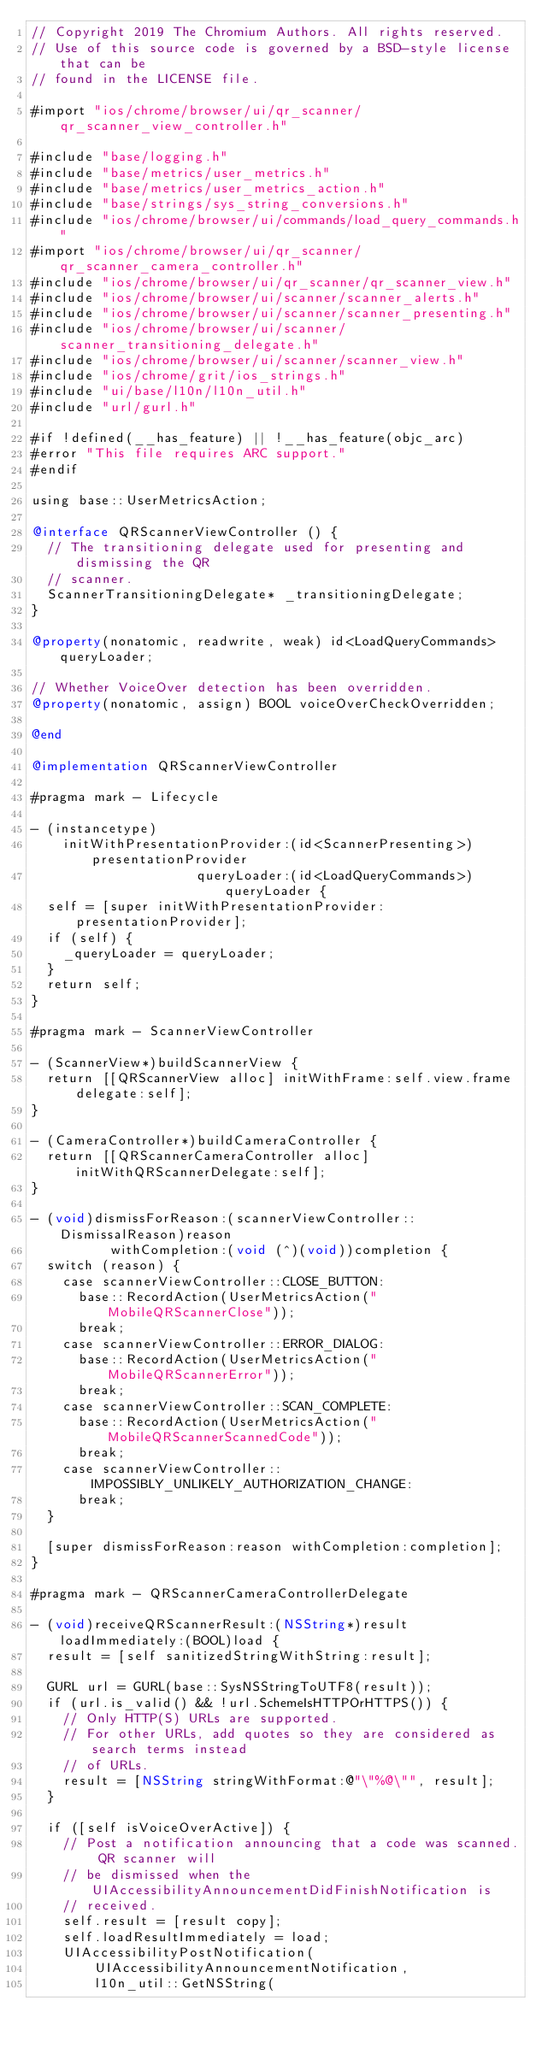<code> <loc_0><loc_0><loc_500><loc_500><_ObjectiveC_>// Copyright 2019 The Chromium Authors. All rights reserved.
// Use of this source code is governed by a BSD-style license that can be
// found in the LICENSE file.

#import "ios/chrome/browser/ui/qr_scanner/qr_scanner_view_controller.h"

#include "base/logging.h"
#include "base/metrics/user_metrics.h"
#include "base/metrics/user_metrics_action.h"
#include "base/strings/sys_string_conversions.h"
#include "ios/chrome/browser/ui/commands/load_query_commands.h"
#import "ios/chrome/browser/ui/qr_scanner/qr_scanner_camera_controller.h"
#include "ios/chrome/browser/ui/qr_scanner/qr_scanner_view.h"
#include "ios/chrome/browser/ui/scanner/scanner_alerts.h"
#include "ios/chrome/browser/ui/scanner/scanner_presenting.h"
#include "ios/chrome/browser/ui/scanner/scanner_transitioning_delegate.h"
#include "ios/chrome/browser/ui/scanner/scanner_view.h"
#include "ios/chrome/grit/ios_strings.h"
#include "ui/base/l10n/l10n_util.h"
#include "url/gurl.h"

#if !defined(__has_feature) || !__has_feature(objc_arc)
#error "This file requires ARC support."
#endif

using base::UserMetricsAction;

@interface QRScannerViewController () {
  // The transitioning delegate used for presenting and dismissing the QR
  // scanner.
  ScannerTransitioningDelegate* _transitioningDelegate;
}

@property(nonatomic, readwrite, weak) id<LoadQueryCommands> queryLoader;

// Whether VoiceOver detection has been overridden.
@property(nonatomic, assign) BOOL voiceOverCheckOverridden;

@end

@implementation QRScannerViewController

#pragma mark - Lifecycle

- (instancetype)
    initWithPresentationProvider:(id<ScannerPresenting>)presentationProvider
                     queryLoader:(id<LoadQueryCommands>)queryLoader {
  self = [super initWithPresentationProvider:presentationProvider];
  if (self) {
    _queryLoader = queryLoader;
  }
  return self;
}

#pragma mark - ScannerViewController

- (ScannerView*)buildScannerView {
  return [[QRScannerView alloc] initWithFrame:self.view.frame delegate:self];
}

- (CameraController*)buildCameraController {
  return [[QRScannerCameraController alloc] initWithQRScannerDelegate:self];
}

- (void)dismissForReason:(scannerViewController::DismissalReason)reason
          withCompletion:(void (^)(void))completion {
  switch (reason) {
    case scannerViewController::CLOSE_BUTTON:
      base::RecordAction(UserMetricsAction("MobileQRScannerClose"));
      break;
    case scannerViewController::ERROR_DIALOG:
      base::RecordAction(UserMetricsAction("MobileQRScannerError"));
      break;
    case scannerViewController::SCAN_COMPLETE:
      base::RecordAction(UserMetricsAction("MobileQRScannerScannedCode"));
      break;
    case scannerViewController::IMPOSSIBLY_UNLIKELY_AUTHORIZATION_CHANGE:
      break;
  }

  [super dismissForReason:reason withCompletion:completion];
}

#pragma mark - QRScannerCameraControllerDelegate

- (void)receiveQRScannerResult:(NSString*)result loadImmediately:(BOOL)load {
  result = [self sanitizedStringWithString:result];

  GURL url = GURL(base::SysNSStringToUTF8(result));
  if (url.is_valid() && !url.SchemeIsHTTPOrHTTPS()) {
    // Only HTTP(S) URLs are supported.
    // For other URLs, add quotes so they are considered as search terms instead
    // of URLs.
    result = [NSString stringWithFormat:@"\"%@\"", result];
  }

  if ([self isVoiceOverActive]) {
    // Post a notification announcing that a code was scanned. QR scanner will
    // be dismissed when the UIAccessibilityAnnouncementDidFinishNotification is
    // received.
    self.result = [result copy];
    self.loadResultImmediately = load;
    UIAccessibilityPostNotification(
        UIAccessibilityAnnouncementNotification,
        l10n_util::GetNSString(</code> 